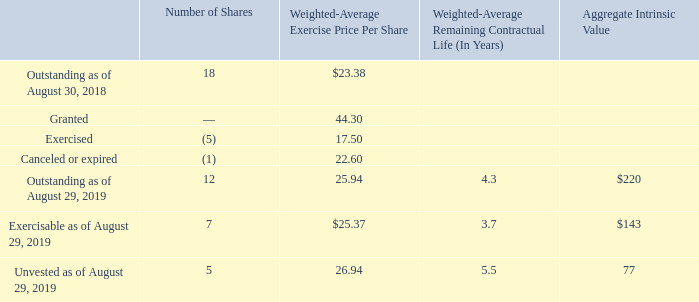Stock Options
Our stock options are generally exercisable in increments of either one-fourth or one-third per year beginning one year from the date of grant. Stock options issued after February 2014 expire eight years from the date of grant. Options issued prior to February 2014 expire six years from the date of grant. Option activity for 2019 is summarized as follows:
The total intrinsic value was $108 million, $446 million, and $198 million for options exercised in 2019, 2018, and 2017, respectively.
How are the stock options generally exercised? In increments of either one-fourth or one-third per year beginning one year from the date of grant. For which stock options expire eight years from the date of the grant? Issued after february 2014. What was the total intrinsic value for options exercised in 2018? $446 million. What is the price of outstanding shares as of August 29, 2019? 12*25.94 
Answer: 311.28. What is the proportion of exercisable shares among the total outstanding shares as of August 29, 2019? 7/12 
Answer: 0.58. What is the total price of shares that were exercised, canceled, or expired? (5*17.50)+(1*22.60)
Answer: 110.1. 